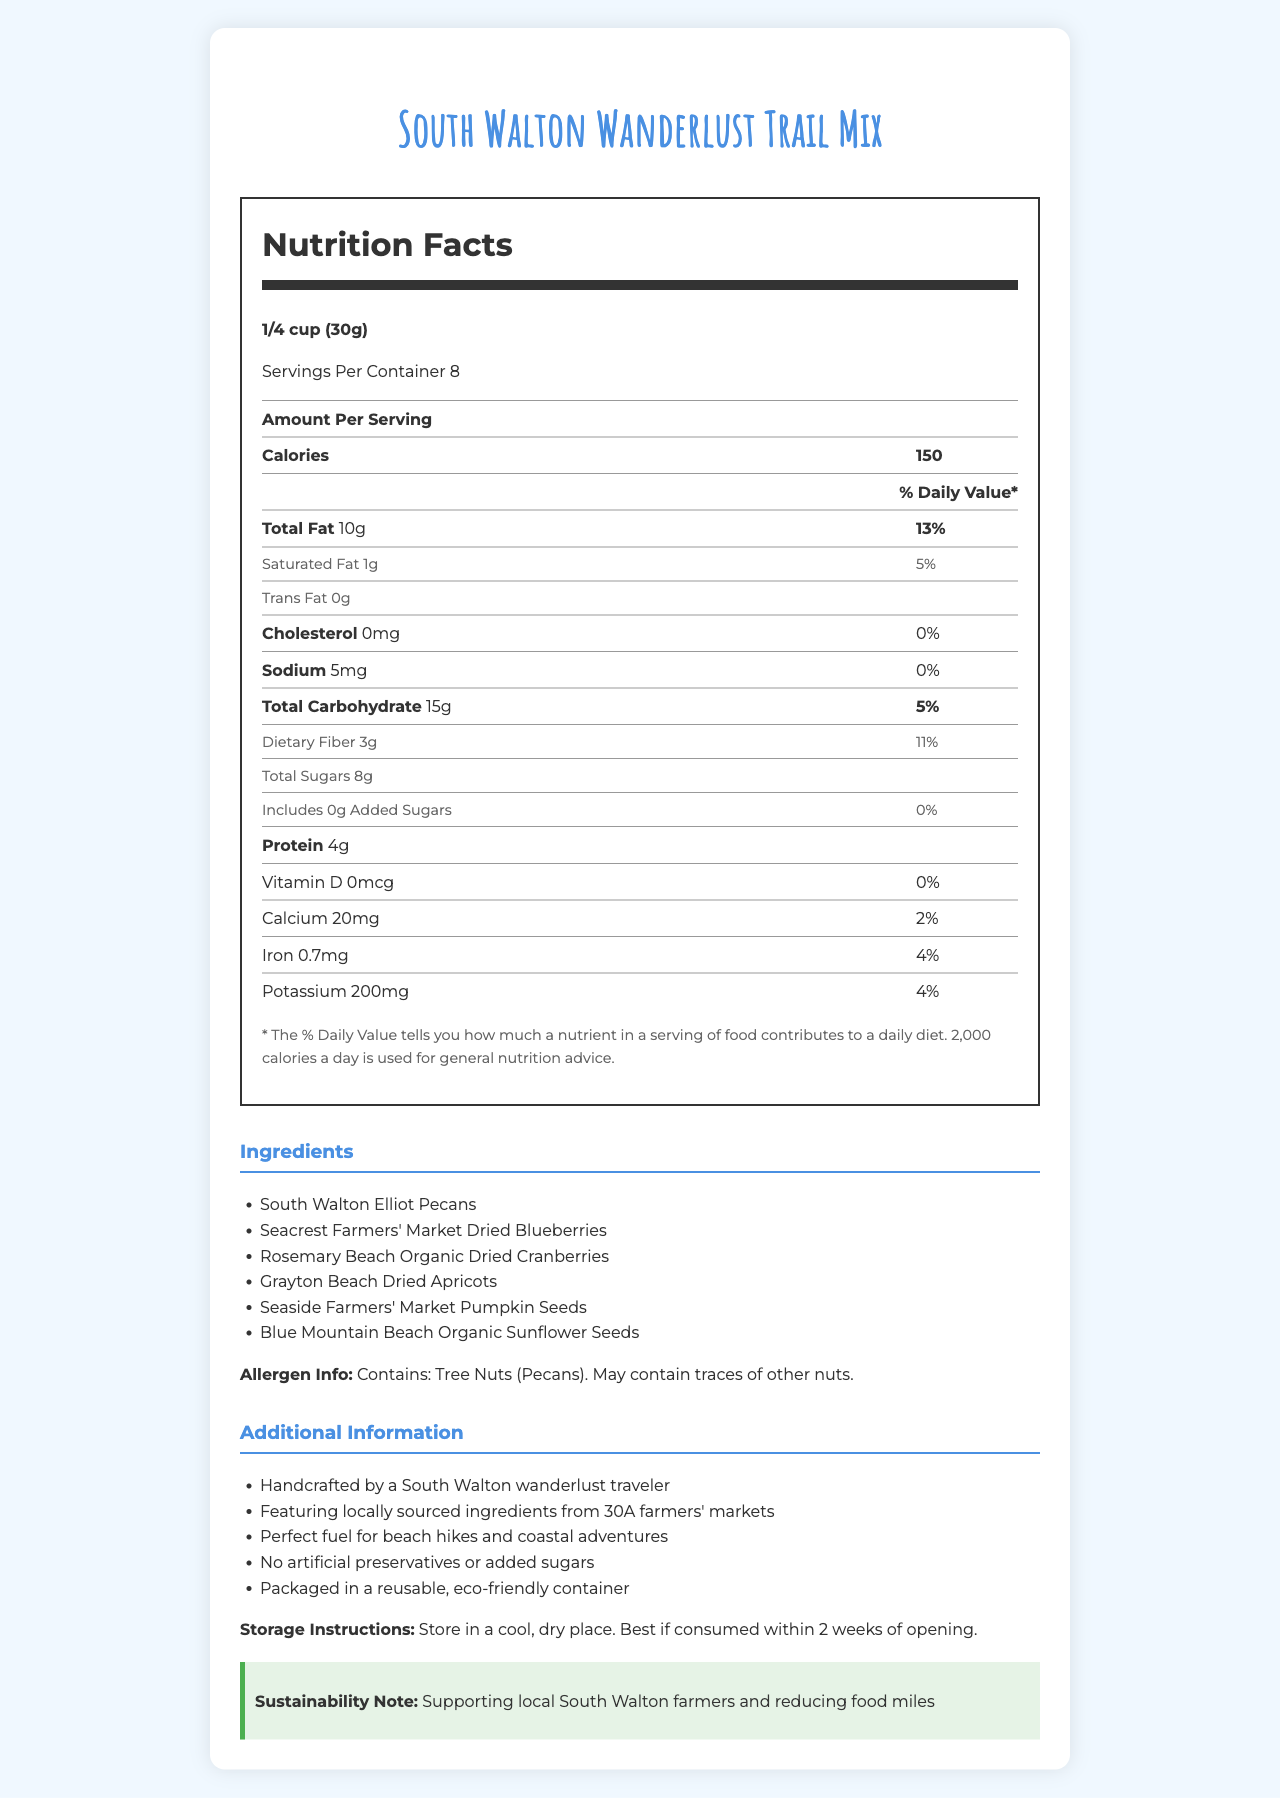what is the serving size? The serving size is listed as 1/4 cup (30g) at the top of the Nutrition Facts section.
Answer: 1/4 cup (30g) how many servings per container are there? It is clearly stated that there are 8 servings per container.
Answer: 8 how many calories are in one serving? The document states that each serving contains 150 calories.
Answer: 150 what is the total fat content per serving? It is listed under the Total Fat section that each serving contains 10g of total fat.
Answer: 10g what percentage of daily value does saturated fat represent? The percentage of daily value for saturated fat is clearly stated as 5%.
Answer: 5% how much protein does each serving provide? The protein content in each serving is listed as 4g.
Answer: 4g which ingredient contains tree nuts? The allergen information states that the trail mix contains tree nuts from South Walton Elliot Pecans.
Answer: South Walton Elliot Pecans how should the trail mix be stored? The storage instructions state to store the mix in a cool, dry place and consume within 2 weeks of opening.
Answer: In a cool, dry place. Best if consumed within 2 weeks of opening. what is the main source of sugars in the trail mix? A. Added Sugars B. Natural Sugars C. Both The document states that there are 0g of added sugars, implying that the sugars come from natural sources.
Answer: B. Natural Sugars which of the following is NOT an ingredient in the trail mix? 1. South Walton Elliot Pecans 2. Seaside Farmers' Market Pumpkin Seeds 3. Rosemary Beach Dried Cherries 4. Grayton Beach Dried Apricots Rosemary Beach Dried Cherries are not listed as an ingredient, while the others are mentioned.
Answer: 3. Rosemary Beach Dried Cherries is this trail mix crafted with locally sourced ingredients? The additional information section specifies that the ingredients are locally sourced from 30A farmers' markets.
Answer: Yes does the trail mix contain any artificial preservatives? The additional information explicitly states that there are no artificial preservatives or added sugars.
Answer: No summarize the document. The explanation provides a comprehensive summary of the information presented in the document.
Answer: This document provides detailed nutritional information about a homemade trail mix featuring local pecans and dried fruits from South Walton farmers' markets. Each serving size of 1/4 cup (30g) contains 150 calories, 10g of total fat, 15g of carbohydrates, and 4g of protein, among other nutrients. The ingredients include various nuts and dried fruits, with an allergen warning for tree nuts. Additional directions suggest storing the trail mix in a cool, dry place and mention several points about sustainability and local sourcing. The mix is handcrafted without artificial preservatives or added sugars. how long does it take to make this trail mix? The document does not specify the time required to make the trail mix, so this information cannot be determined from the visual data provided.
Answer: Cannot be determined 